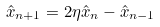<formula> <loc_0><loc_0><loc_500><loc_500>\hat { x } _ { n + 1 } = 2 \eta \hat { x } _ { n } - \hat { x } _ { n - 1 }</formula> 